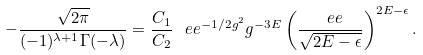Convert formula to latex. <formula><loc_0><loc_0><loc_500><loc_500>- \frac { \sqrt { 2 \pi } } { ( - 1 ) ^ { \lambda + 1 } \Gamma ( - \lambda ) } = \frac { C _ { 1 } } { C _ { 2 } } \, \ e e ^ { - 1 / 2 g ^ { 2 } } g ^ { - 3 E } \left ( \frac { \ e e } { \sqrt { 2 E - \epsilon } } \right ) ^ { 2 E - \epsilon } .</formula> 